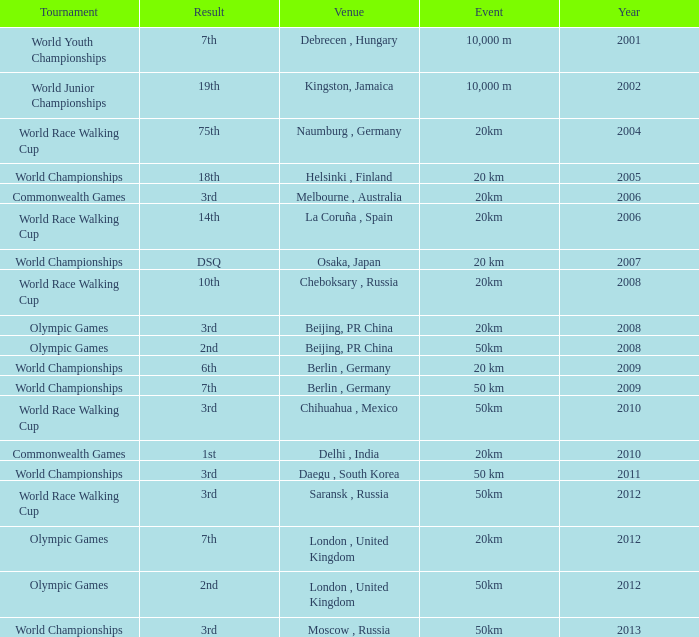What is earliest year that had a 50km event with a 2nd place result played in London, United Kingdom? 2012.0. 